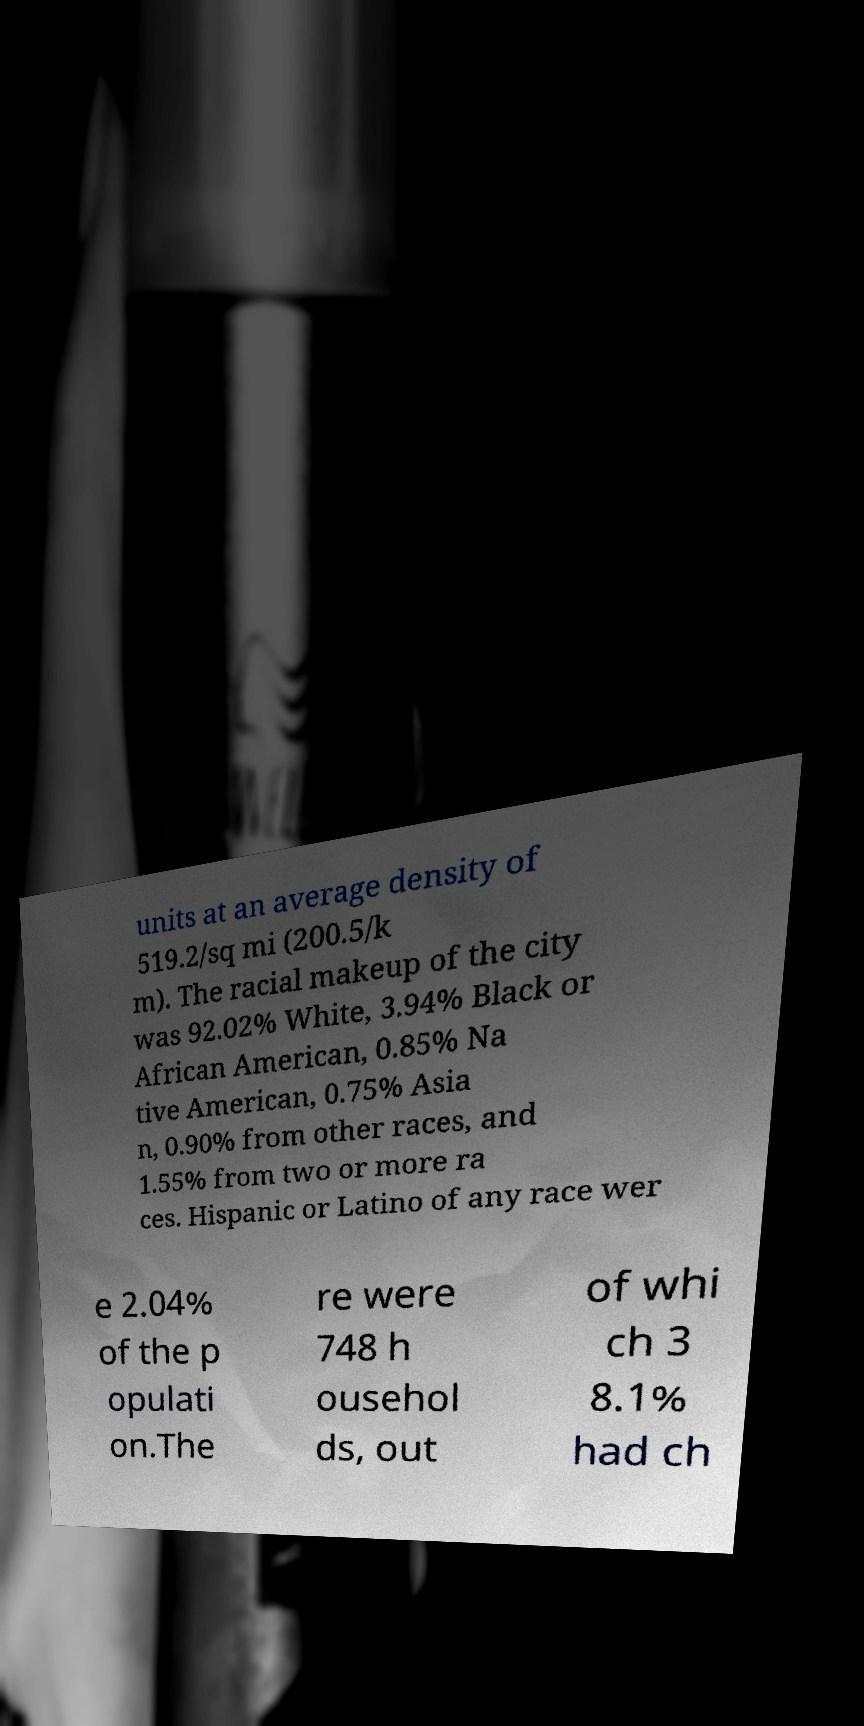Could you extract and type out the text from this image? units at an average density of 519.2/sq mi (200.5/k m). The racial makeup of the city was 92.02% White, 3.94% Black or African American, 0.85% Na tive American, 0.75% Asia n, 0.90% from other races, and 1.55% from two or more ra ces. Hispanic or Latino of any race wer e 2.04% of the p opulati on.The re were 748 h ousehol ds, out of whi ch 3 8.1% had ch 